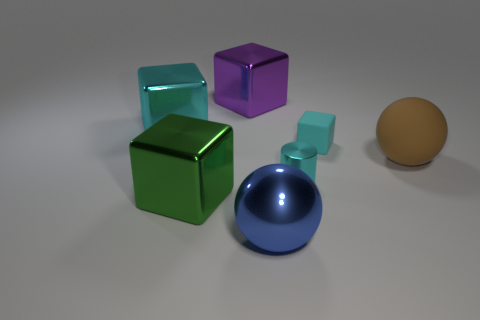There is a big matte thing that is the same shape as the large blue shiny thing; what color is it?
Provide a succinct answer. Brown. Are there fewer big cubes that are behind the green shiny block than blocks that are behind the small metallic thing?
Give a very brief answer. Yes. How many other objects are there of the same shape as the brown thing?
Make the answer very short. 1. Are there fewer large brown things in front of the matte sphere than small yellow matte balls?
Offer a very short reply. No. There is a cyan block left of the large metal ball; what material is it?
Offer a very short reply. Metal. What number of other objects are the same size as the purple thing?
Make the answer very short. 4. Are there fewer tiny metallic cylinders than large gray rubber blocks?
Keep it short and to the point. No. What shape is the green object?
Your answer should be very brief. Cube. There is a large shiny object that is to the left of the large green metallic object; is it the same color as the metallic cylinder?
Your answer should be compact. Yes. There is a large metal object that is behind the matte cube and in front of the big purple thing; what shape is it?
Give a very brief answer. Cube. 